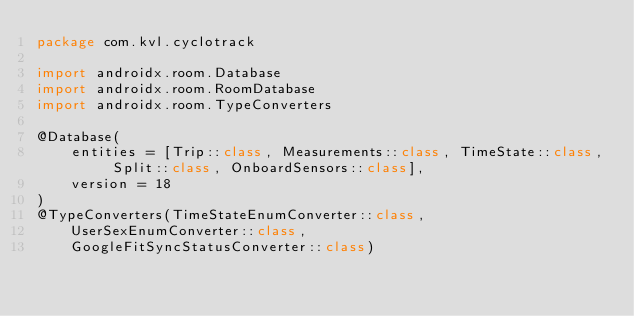<code> <loc_0><loc_0><loc_500><loc_500><_Kotlin_>package com.kvl.cyclotrack

import androidx.room.Database
import androidx.room.RoomDatabase
import androidx.room.TypeConverters

@Database(
    entities = [Trip::class, Measurements::class, TimeState::class, Split::class, OnboardSensors::class],
    version = 18
)
@TypeConverters(TimeStateEnumConverter::class,
    UserSexEnumConverter::class,
    GoogleFitSyncStatusConverter::class)</code> 